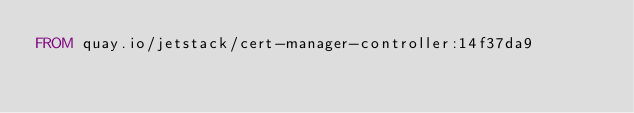<code> <loc_0><loc_0><loc_500><loc_500><_Dockerfile_>FROM quay.io/jetstack/cert-manager-controller:14f37da9
</code> 